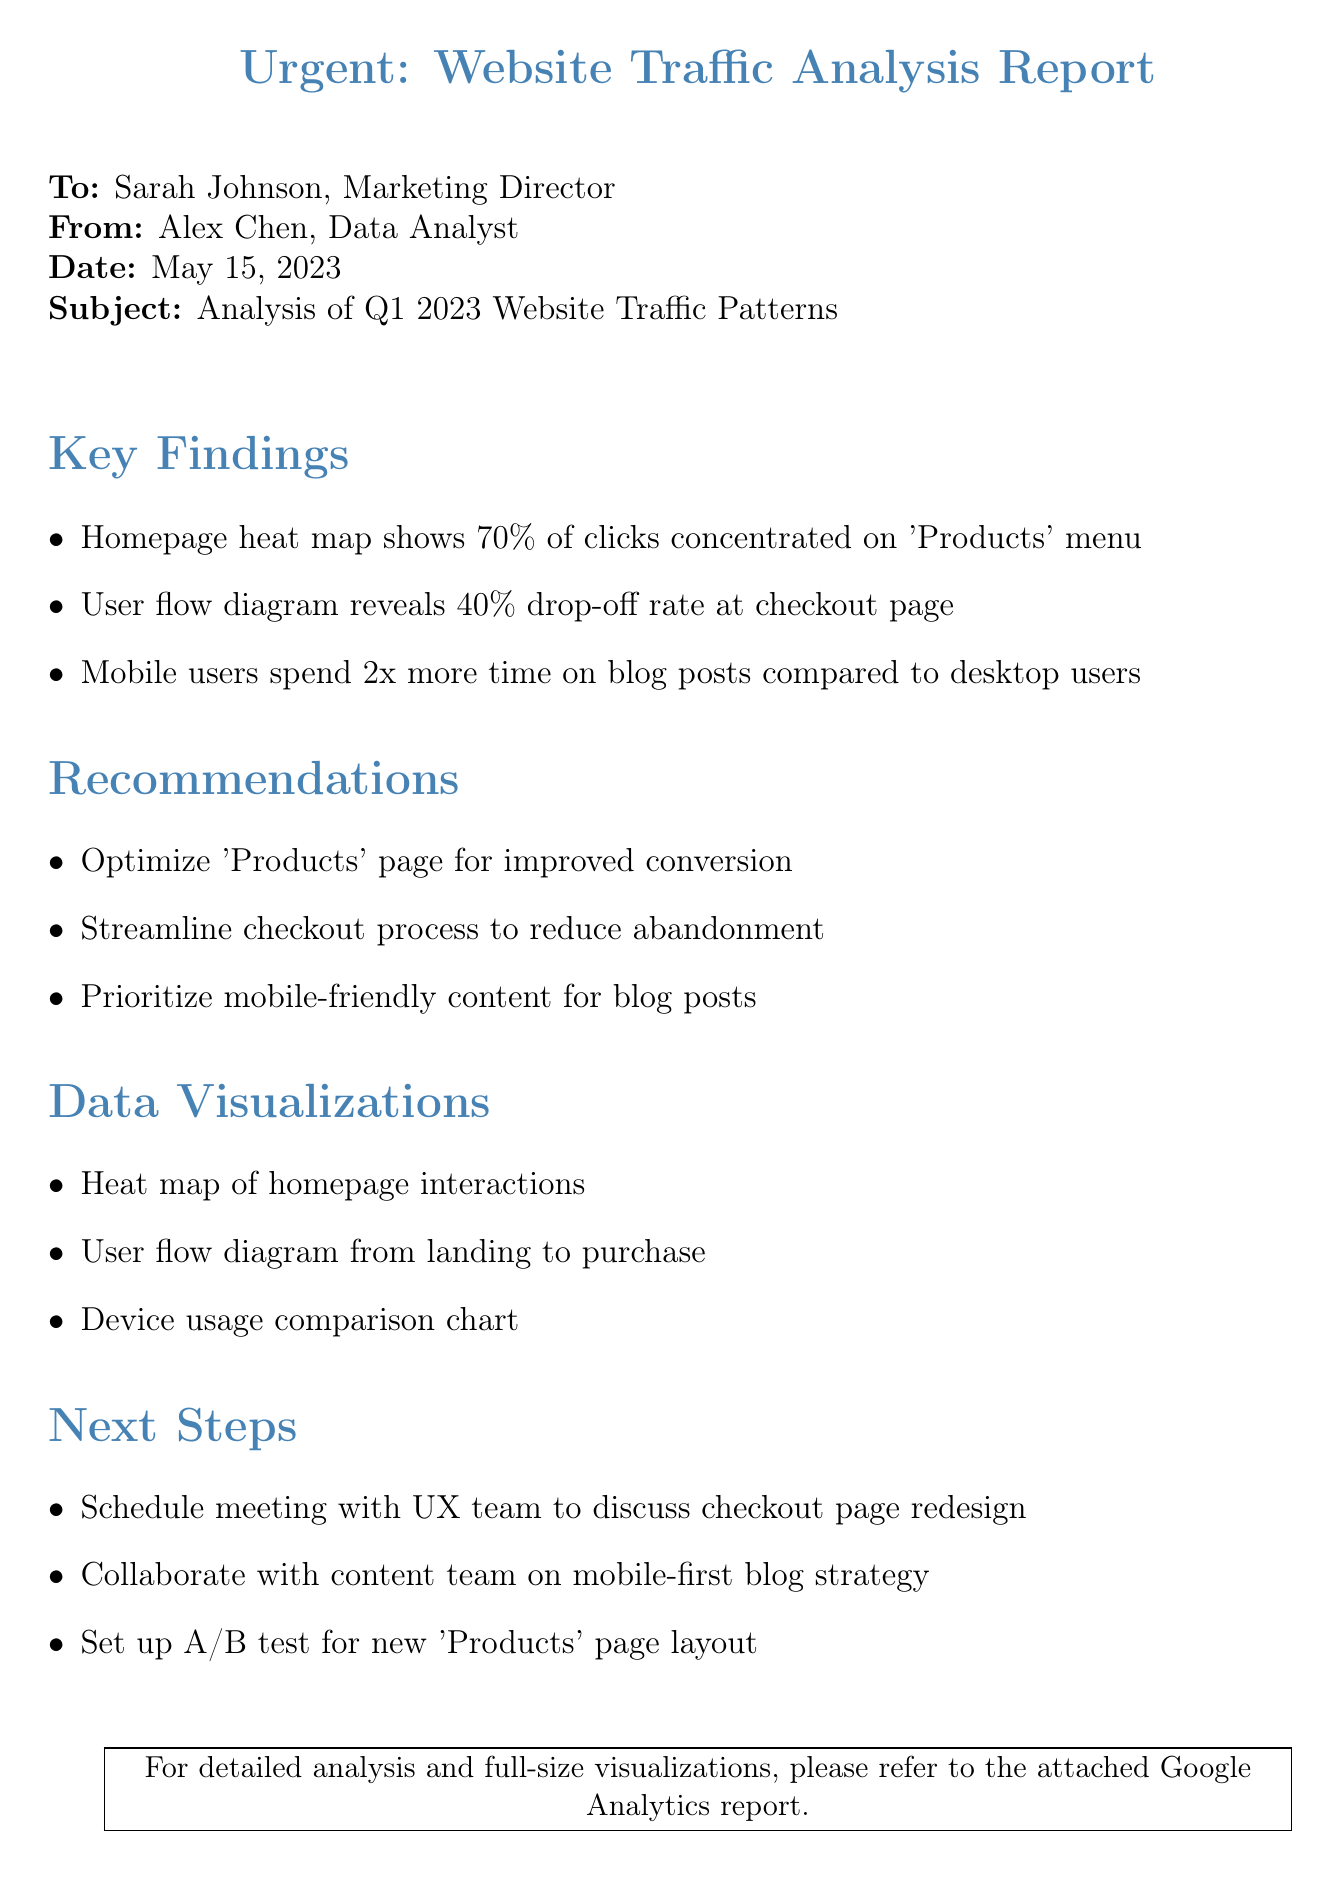what is the date of the report? The date of the report is specified in the header section, which is May 15, 2023.
Answer: May 15, 2023 who is the sender of the report? The sender of the report is identified in the header section as Alex Chen.
Answer: Alex Chen what percentage of clicks is concentrated on 'Products' menu? The heat map analysis indicates that 70% of clicks are focused on the 'Products' menu.
Answer: 70% what is the drop-off rate at the checkout page? The user flow diagram reveals that the drop-off rate at the checkout page is 40%.
Answer: 40% how much time do mobile users spend on blog posts compared to desktop users? The analysis shows that mobile users spend 2x more time on blog posts when compared to desktop users.
Answer: 2x what is one of the recommendations provided in the document? The document recommends optimizing the 'Products' page for improved conversion.
Answer: Optimize 'Products' page what type of visualizations are included in the data visualizations section? The data visualizations section lists three types of visualizations, including heat map of homepage interactions.
Answer: Heat map of homepage interactions which team should be met with to discuss checkout page redesign? The document indicates that a meeting should be scheduled with the UX team to discuss the checkout page redesign.
Answer: UX team what is one of the next steps mentioned in the document? The next steps section suggests collaborating with the content team on a mobile-first blog strategy.
Answer: Collaborate with content team on mobile-first blog strategy 